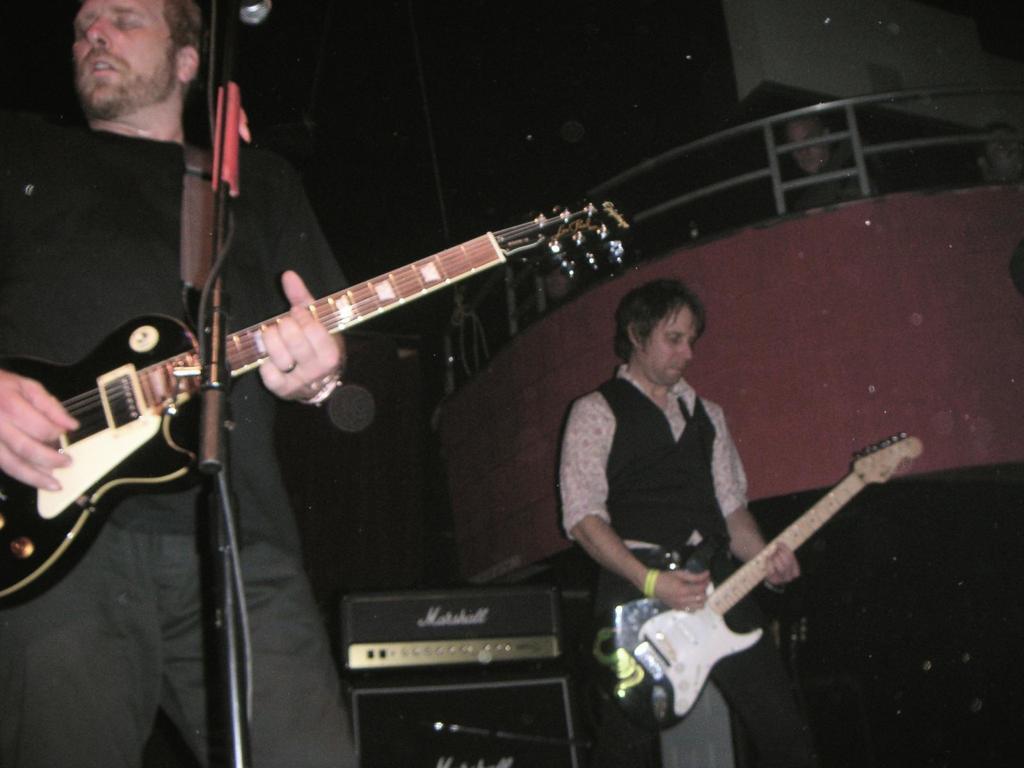Describe this image in one or two sentences. As we can see in the image, there are two people holding guitar in their hands. In front of him there is a mic. 